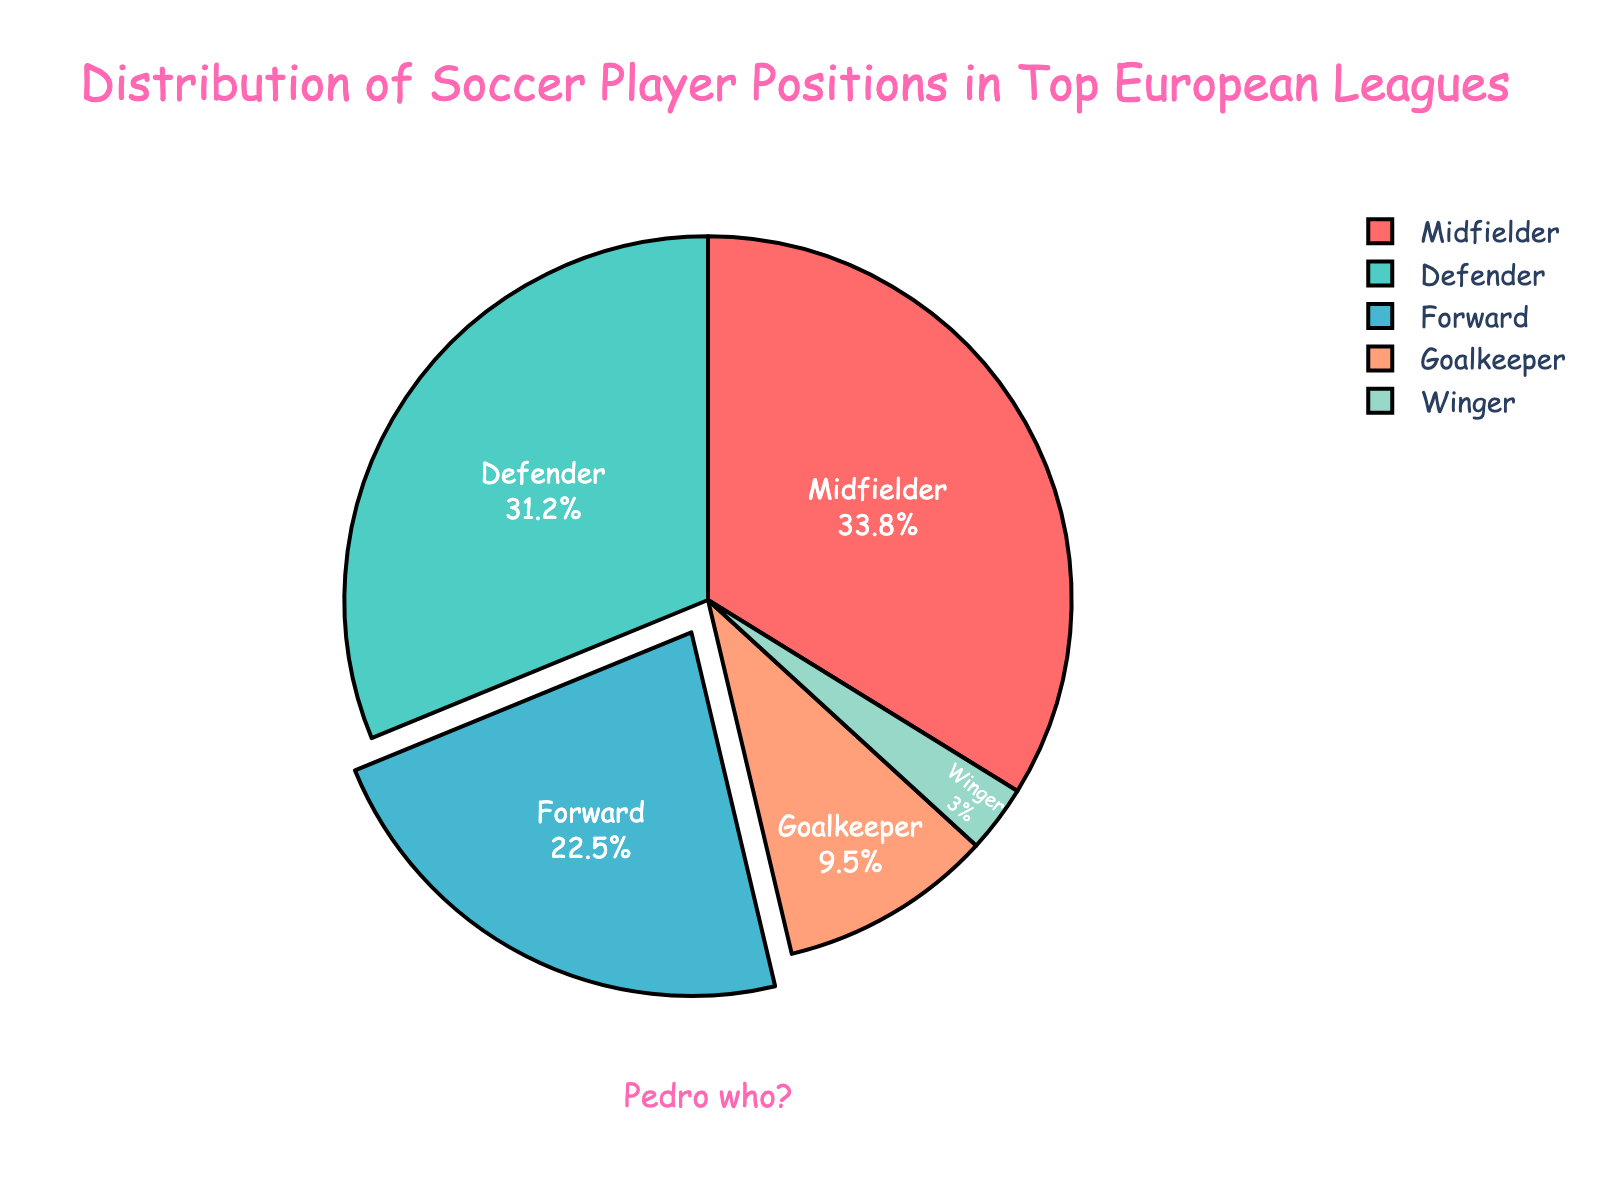Which position has the highest percentage in the distribution? Look at the pie chart and identify the segment with the largest size. The Midfielder segment is the largest.
Answer: Midfielder What is the combined percentage of Forwards and Goalkeepers? Sum the percentages for Forwards (22.5%) and Goalkeepers (9.5%). The combined percentage is 22.5 + 9.5 = 32.0%.
Answer: 32.0% Which position has a lower percentage share, Winger or Goalkeeper? Compare the percentages for Winger (3.0%) and Goalkeeper (9.5%). Winger has a lower percentage share.
Answer: Winger How much larger is the percentage of Defenders compared to Wingers? Subtract the percentage of Wingers (3.0%) from the percentage of Defenders (31.2%). The difference is 31.2 - 3.0 = 28.2%.
Answer: 28.2% Which positions collectively make up more than 50% of the distribution? Add the percentages of the positions and identify which groups exceed 50%. The sum of Midfielders (33.8%) and Defenders (31.2%) is 65%, which is more than 50%.
Answer: Midfielders and Defenders What is the smallest position percentage and what color represents it? Identify the position with the smallest percentage (Winger at 3%) and determine its color from the pie chart. Wingers are represented by light blue.
Answer: Winger, light blue Are there more Defenders or Forwards? Compare the percentages of Defenders (31.2%) and Forwards (22.5%). Defenders have a higher percentage.
Answer: Defenders What is the average percentage of Goalkeepers, Forwards, and Wingers? Sum the percentages of Goalkeepers (9.5%), Forwards (22.5%), and Wingers (3.0%). Divide the sum by 3. (9.5 + 22.5 + 3.0) / 3 = 11.67%.
Answer: 11.67% Which position is emphasized with an offset/pulled apart in the pie chart visualization? Look for the segment that is slightly pulled away from the center of the pie chart. The Forward segment is emphasized.
Answer: Forward 